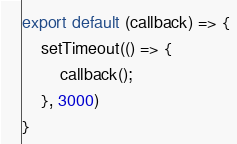<code> <loc_0><loc_0><loc_500><loc_500><_JavaScript_>export default (callback) => {
    setTimeout(() => {
        callback();
    }, 3000)
}</code> 